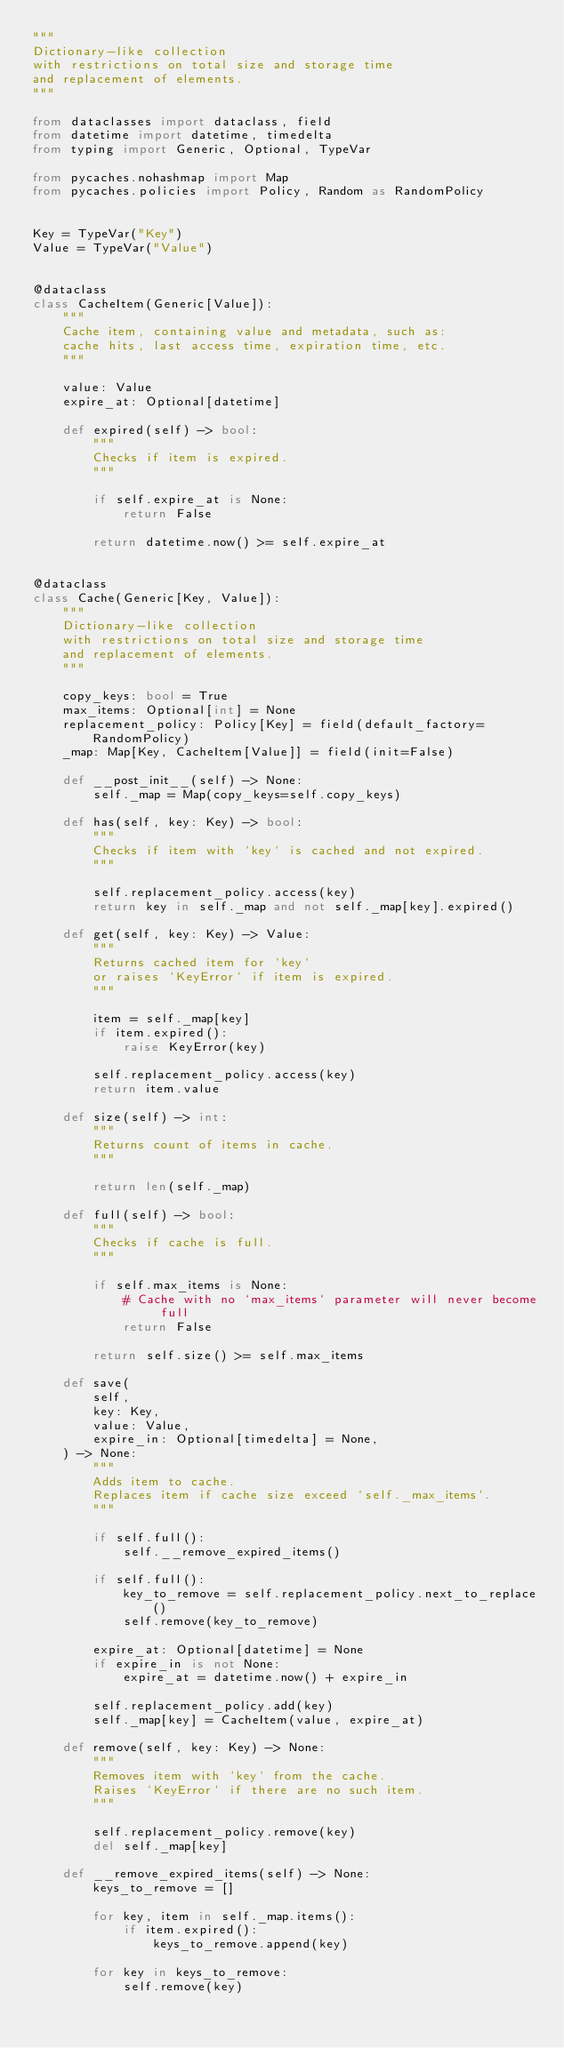Convert code to text. <code><loc_0><loc_0><loc_500><loc_500><_Python_>"""
Dictionary-like collection
with restrictions on total size and storage time
and replacement of elements.
"""

from dataclasses import dataclass, field
from datetime import datetime, timedelta
from typing import Generic, Optional, TypeVar

from pycaches.nohashmap import Map
from pycaches.policies import Policy, Random as RandomPolicy


Key = TypeVar("Key")
Value = TypeVar("Value")


@dataclass
class CacheItem(Generic[Value]):
    """
    Cache item, containing value and metadata, such as:
    cache hits, last access time, expiration time, etc.
    """

    value: Value
    expire_at: Optional[datetime]

    def expired(self) -> bool:
        """
        Checks if item is expired.
        """

        if self.expire_at is None:
            return False

        return datetime.now() >= self.expire_at


@dataclass
class Cache(Generic[Key, Value]):
    """
    Dictionary-like collection
    with restrictions on total size and storage time
    and replacement of elements.
    """

    copy_keys: bool = True
    max_items: Optional[int] = None
    replacement_policy: Policy[Key] = field(default_factory=RandomPolicy)
    _map: Map[Key, CacheItem[Value]] = field(init=False)

    def __post_init__(self) -> None:
        self._map = Map(copy_keys=self.copy_keys)

    def has(self, key: Key) -> bool:
        """
        Checks if item with `key` is cached and not expired.
        """

        self.replacement_policy.access(key)
        return key in self._map and not self._map[key].expired()

    def get(self, key: Key) -> Value:
        """
        Returns cached item for `key`
        or raises `KeyError` if item is expired.
        """

        item = self._map[key]
        if item.expired():
            raise KeyError(key)

        self.replacement_policy.access(key)
        return item.value

    def size(self) -> int:
        """
        Returns count of items in cache.
        """

        return len(self._map)

    def full(self) -> bool:
        """
        Checks if cache is full.
        """

        if self.max_items is None:
            # Cache with no `max_items` parameter will never become full
            return False

        return self.size() >= self.max_items

    def save(
        self,
        key: Key,
        value: Value,
        expire_in: Optional[timedelta] = None,
    ) -> None:
        """
        Adds item to cache.
        Replaces item if cache size exceed `self._max_items`.
        """

        if self.full():
            self.__remove_expired_items()

        if self.full():
            key_to_remove = self.replacement_policy.next_to_replace()
            self.remove(key_to_remove)

        expire_at: Optional[datetime] = None
        if expire_in is not None:
            expire_at = datetime.now() + expire_in

        self.replacement_policy.add(key)
        self._map[key] = CacheItem(value, expire_at)

    def remove(self, key: Key) -> None:
        """
        Removes item with `key` from the cache.
        Raises `KeyError` if there are no such item.
        """

        self.replacement_policy.remove(key)
        del self._map[key]

    def __remove_expired_items(self) -> None:
        keys_to_remove = []

        for key, item in self._map.items():
            if item.expired():
                keys_to_remove.append(key)

        for key in keys_to_remove:
            self.remove(key)
</code> 